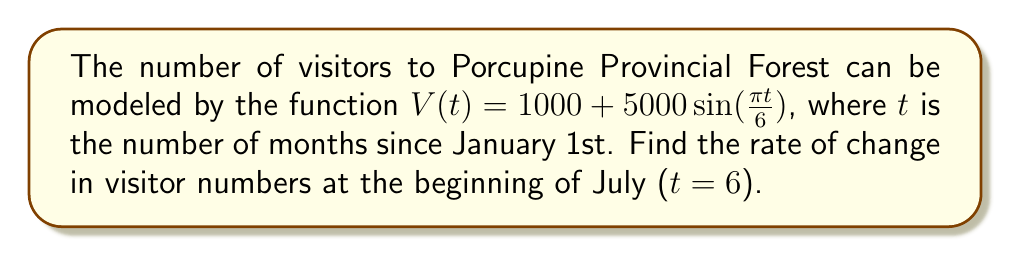Provide a solution to this math problem. To find the rate of change in visitor numbers, we need to calculate the derivative of the function $V(t)$ and evaluate it at $t = 6$.

Step 1: Find the derivative of $V(t)$
$$V(t) = 1000 + 5000\sin(\frac{\pi t}{6})$$
$$V'(t) = 5000 \cdot \frac{\pi}{6} \cos(\frac{\pi t}{6})$$

Step 2: Simplify the derivative
$$V'(t) = \frac{5000\pi}{6} \cos(\frac{\pi t}{6})$$

Step 3: Evaluate the derivative at $t = 6$ (beginning of July)
$$V'(6) = \frac{5000\pi}{6} \cos(\frac{\pi \cdot 6}{6})$$
$$V'(6) = \frac{5000\pi}{6} \cos(\pi)$$

Step 4: Simplify the result
$$V'(6) = \frac{5000\pi}{6} \cdot (-1)$$
$$V'(6) = -\frac{5000\pi}{6}$$

Step 5: Calculate the final value
$$V'(6) \approx -2618.0 \text{ visitors/month}$$
Answer: $-\frac{5000\pi}{6}$ visitors/month 